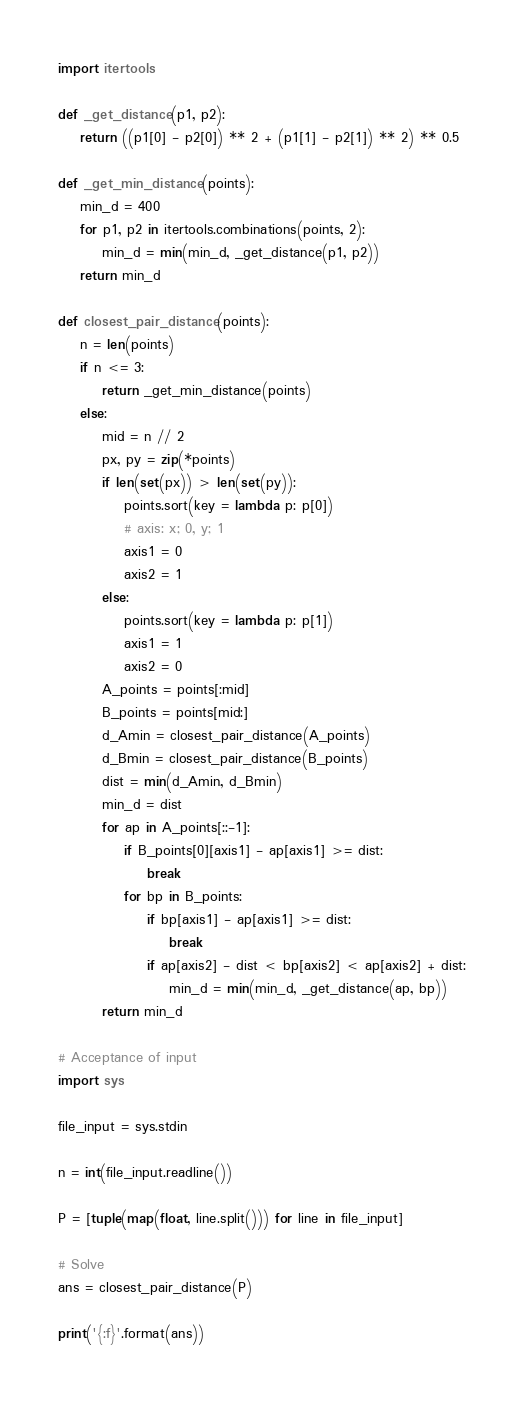Convert code to text. <code><loc_0><loc_0><loc_500><loc_500><_Python_>import itertools

def _get_distance(p1, p2):
    return ((p1[0] - p2[0]) ** 2 + (p1[1] - p2[1]) ** 2) ** 0.5

def _get_min_distance(points):
    min_d = 400
    for p1, p2 in itertools.combinations(points, 2):
        min_d = min(min_d, _get_distance(p1, p2))
    return min_d

def closest_pair_distance(points):
    n = len(points)
    if n <= 3:
        return _get_min_distance(points)
    else:
        mid = n // 2
        px, py = zip(*points)
        if len(set(px)) > len(set(py)):
            points.sort(key = lambda p: p[0])
            # axis: x; 0, y; 1
            axis1 = 0
            axis2 = 1
        else:
            points.sort(key = lambda p: p[1])
            axis1 = 1
            axis2 = 0
        A_points = points[:mid]
        B_points = points[mid:]
        d_Amin = closest_pair_distance(A_points)
        d_Bmin = closest_pair_distance(B_points)
        dist = min(d_Amin, d_Bmin)
        min_d = dist
        for ap in A_points[::-1]:
            if B_points[0][axis1] - ap[axis1] >= dist:
                break
            for bp in B_points:
                if bp[axis1] - ap[axis1] >= dist:
                    break
                if ap[axis2] - dist < bp[axis2] < ap[axis2] + dist:
                    min_d = min(min_d, _get_distance(ap, bp))
        return min_d

# Acceptance of input
import sys

file_input = sys.stdin

n = int(file_input.readline())

P = [tuple(map(float, line.split())) for line in file_input]

# Solve
ans = closest_pair_distance(P)

print('{:f}'.format(ans))</code> 